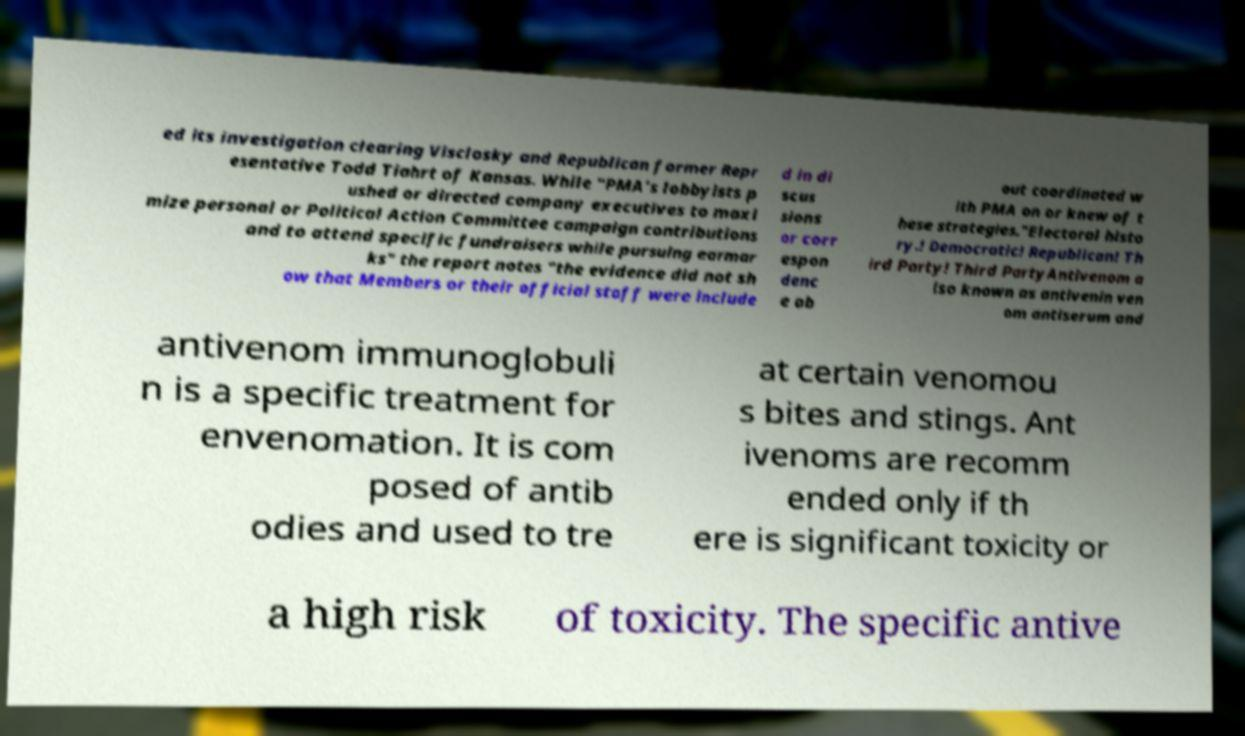Please identify and transcribe the text found in this image. ed its investigation clearing Visclosky and Republican former Repr esentative Todd Tiahrt of Kansas. While "PMA's lobbyists p ushed or directed company executives to maxi mize personal or Political Action Committee campaign contributions and to attend specific fundraisers while pursuing earmar ks" the report notes "the evidence did not sh ow that Members or their official staff were include d in di scus sions or corr espon denc e ab out coordinated w ith PMA on or knew of t hese strategies."Electoral histo ry.! Democratic! Republican! Th ird Party! Third PartyAntivenom a lso known as antivenin ven om antiserum and antivenom immunoglobuli n is a specific treatment for envenomation. It is com posed of antib odies and used to tre at certain venomou s bites and stings. Ant ivenoms are recomm ended only if th ere is significant toxicity or a high risk of toxicity. The specific antive 